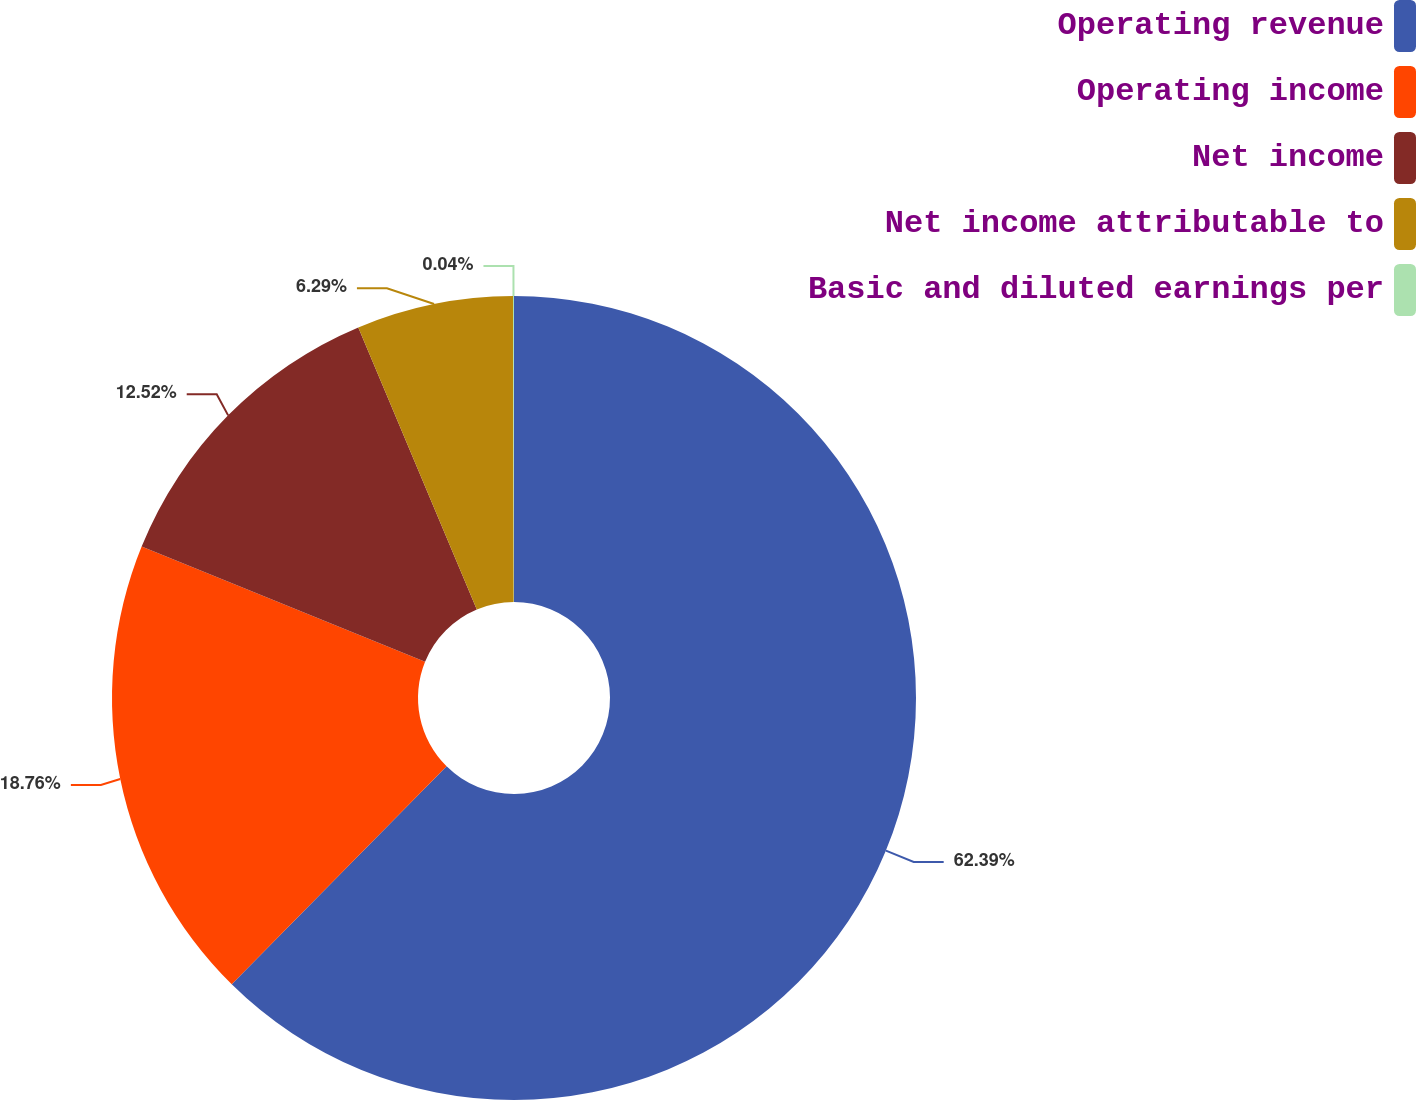Convert chart to OTSL. <chart><loc_0><loc_0><loc_500><loc_500><pie_chart><fcel>Operating revenue<fcel>Operating income<fcel>Net income<fcel>Net income attributable to<fcel>Basic and diluted earnings per<nl><fcel>62.39%<fcel>18.76%<fcel>12.52%<fcel>6.29%<fcel>0.04%<nl></chart> 